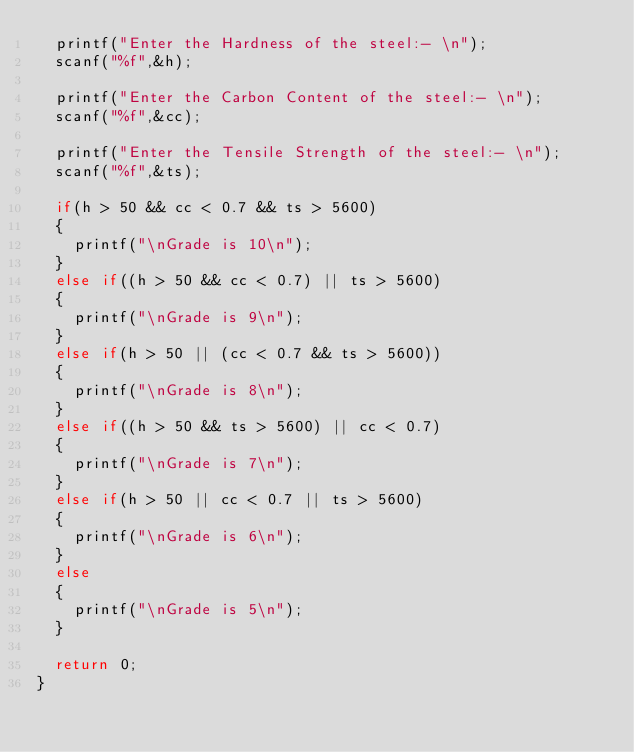<code> <loc_0><loc_0><loc_500><loc_500><_C_>	printf("Enter the Hardness of the steel:- \n");
	scanf("%f",&h);
	
	printf("Enter the Carbon Content of the steel:- \n");
	scanf("%f",&cc);
	
	printf("Enter the Tensile Strength of the steel:- \n");
	scanf("%f",&ts);
	
	if(h > 50 && cc < 0.7 && ts > 5600)
	{
		printf("\nGrade is 10\n");
	}
	else if((h > 50 && cc < 0.7) || ts > 5600)
	{
		printf("\nGrade is 9\n");
	}
	else if(h > 50 || (cc < 0.7 && ts > 5600))
	{
		printf("\nGrade is 8\n");
	}
	else if((h > 50 && ts > 5600) || cc < 0.7)
	{
		printf("\nGrade is 7\n");
	}
	else if(h > 50 || cc < 0.7 || ts > 5600)
	{
		printf("\nGrade is 6\n");
	}
	else
	{
		printf("\nGrade is 5\n");
	}
	
	return 0;
}
</code> 